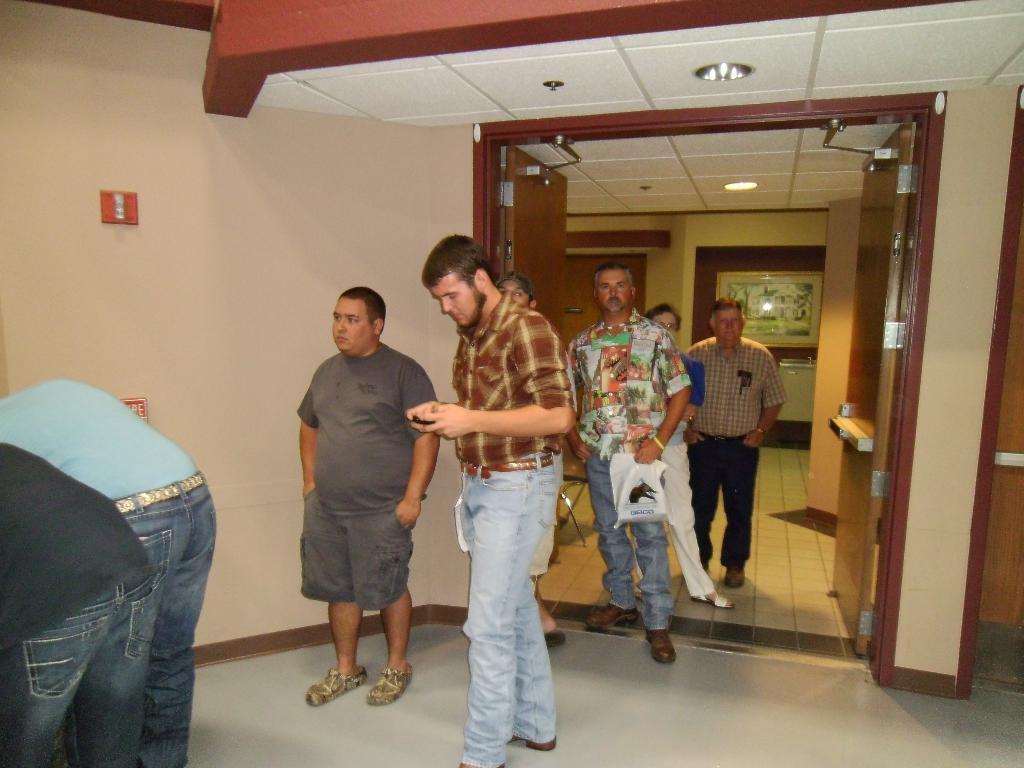In one or two sentences, can you explain what this image depicts? In this image I see the inside of the rooms and I see few people who are on the floor and I see the doors, lights on the ceiling, wall, 2 red color things over here and I see that this man is holding a white color thing in his hand. 